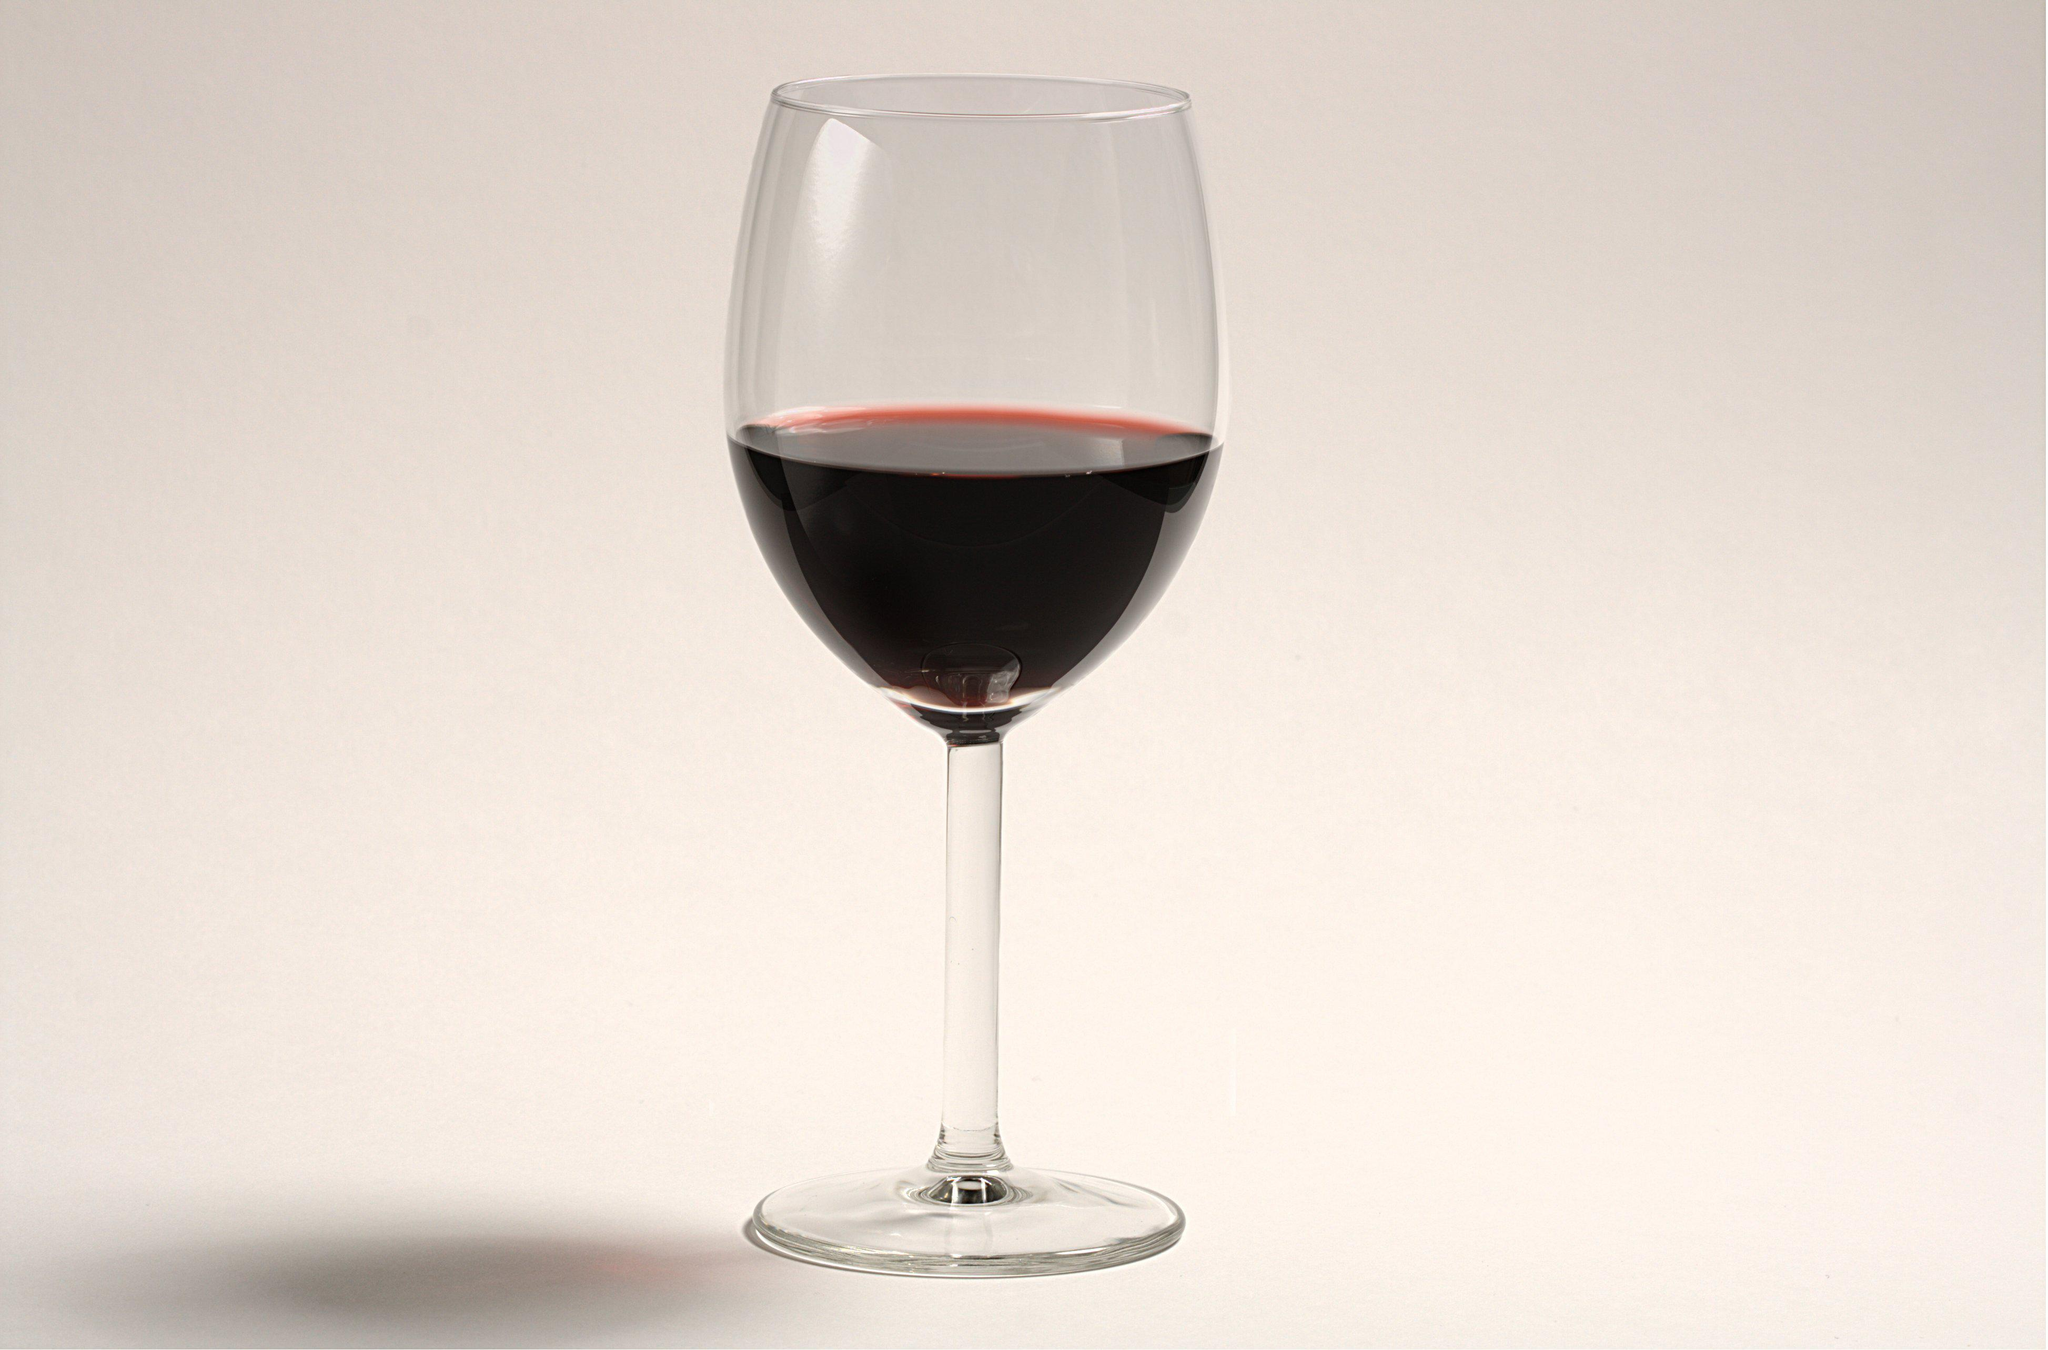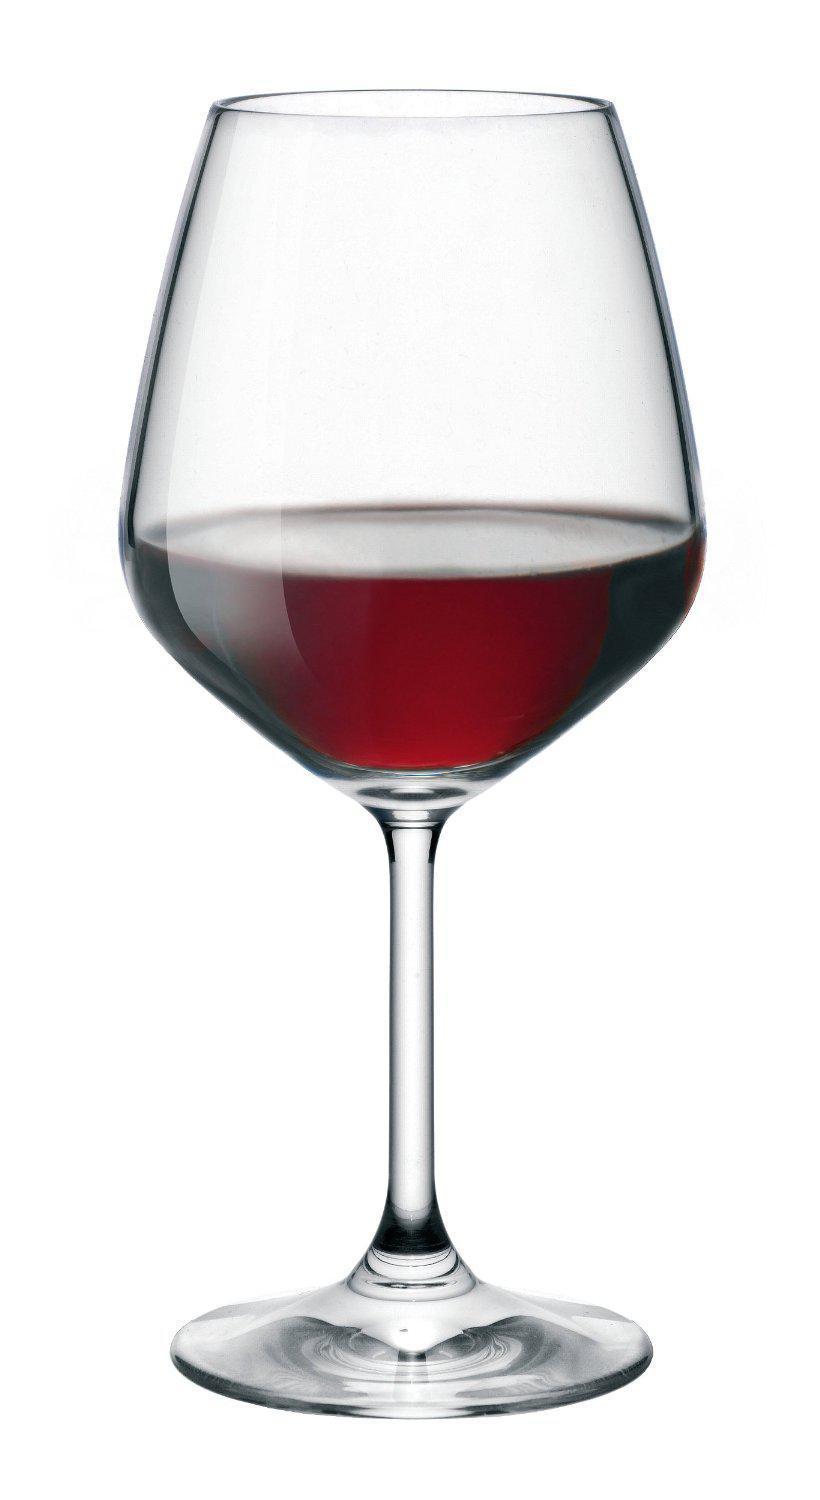The first image is the image on the left, the second image is the image on the right. Assess this claim about the two images: "Wine is pouring into the glass in the image on the right.". Correct or not? Answer yes or no. No. The first image is the image on the left, the second image is the image on the right. For the images displayed, is the sentence "Red wine is pouring into a glass, creating a splash inside the glass." factually correct? Answer yes or no. No. 